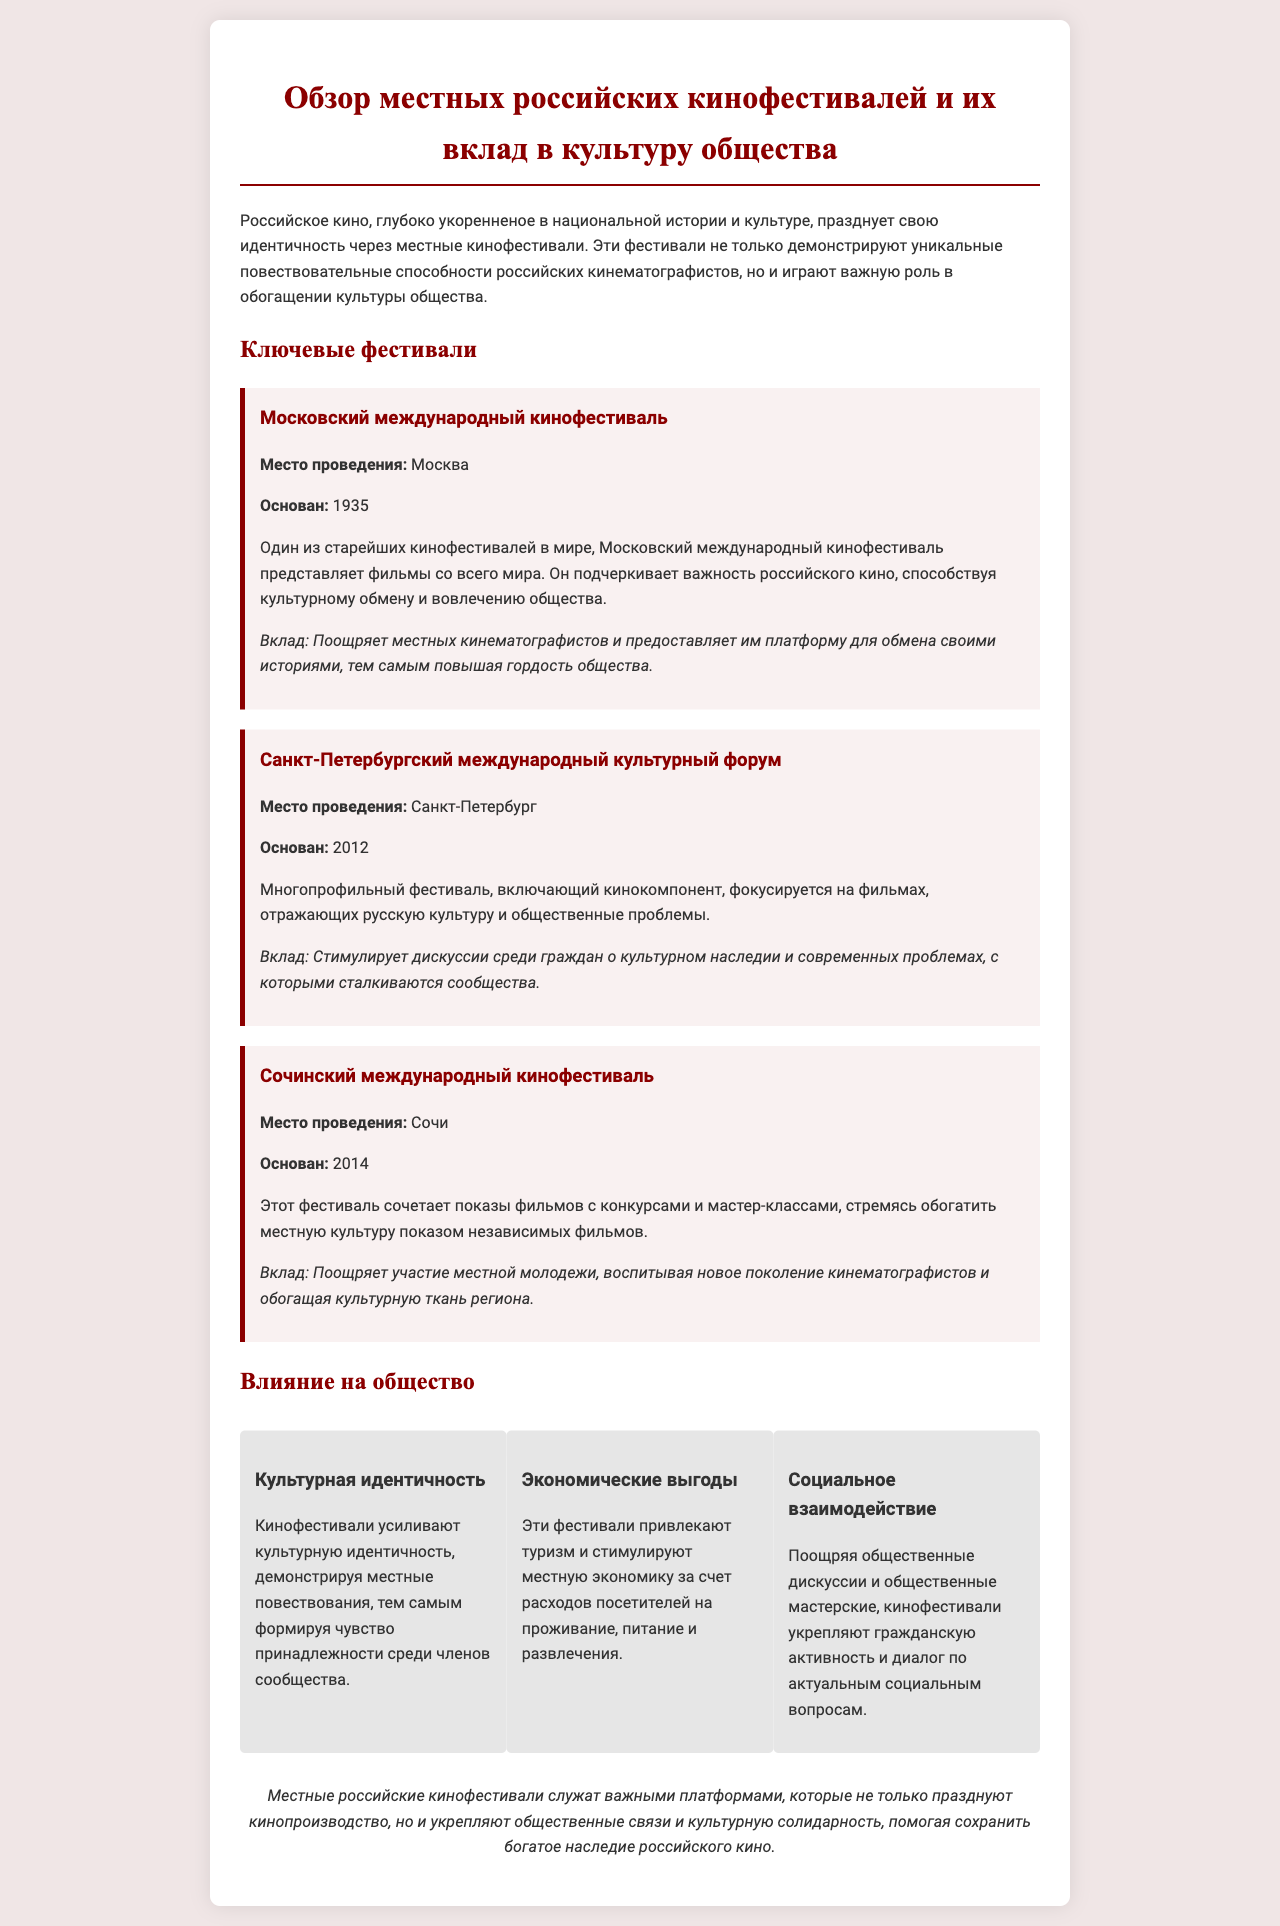what is the founding year of the Moscow International Film Festival? The founding year of the Moscow International Film Festival is mentioned in the document as 1935.
Answer: 1935 where is the Saint Petersburg International Cultural Forum held? The document specifies that the festival takes place in Saint Petersburg.
Answer: Санкт-Петербург what is the contribution of the Sochi International Film Festival? The contribution of the Sochi International Film Festival is detailed as encouraging local youth participation and enriching the cultural fabric of the region.
Answer: Поощряет участие местной молодежи how many key festivals are mentioned in the document? The document lists a total of three key festivals.
Answer: 3 what is one economic benefit of the film festivals mentioned? The document states that these festivals stimulate the local economy through tourism and visitors' spending.
Answer: Туризм what aspect of identity do film festivals strengthen? According to the document, film festivals enhance cultural identity within the community.
Answer: Культурную идентичность when was the Sochi International Film Festival founded? The founding year of the Sochi International Film Festival is noted as 2014 in the document.
Answer: 2014 what type of events does the Sochi International Film Festival include? The document mentions that the Sochi International Film Festival includes screenings, competitions, and master classes.
Answer: Мастер-классы 